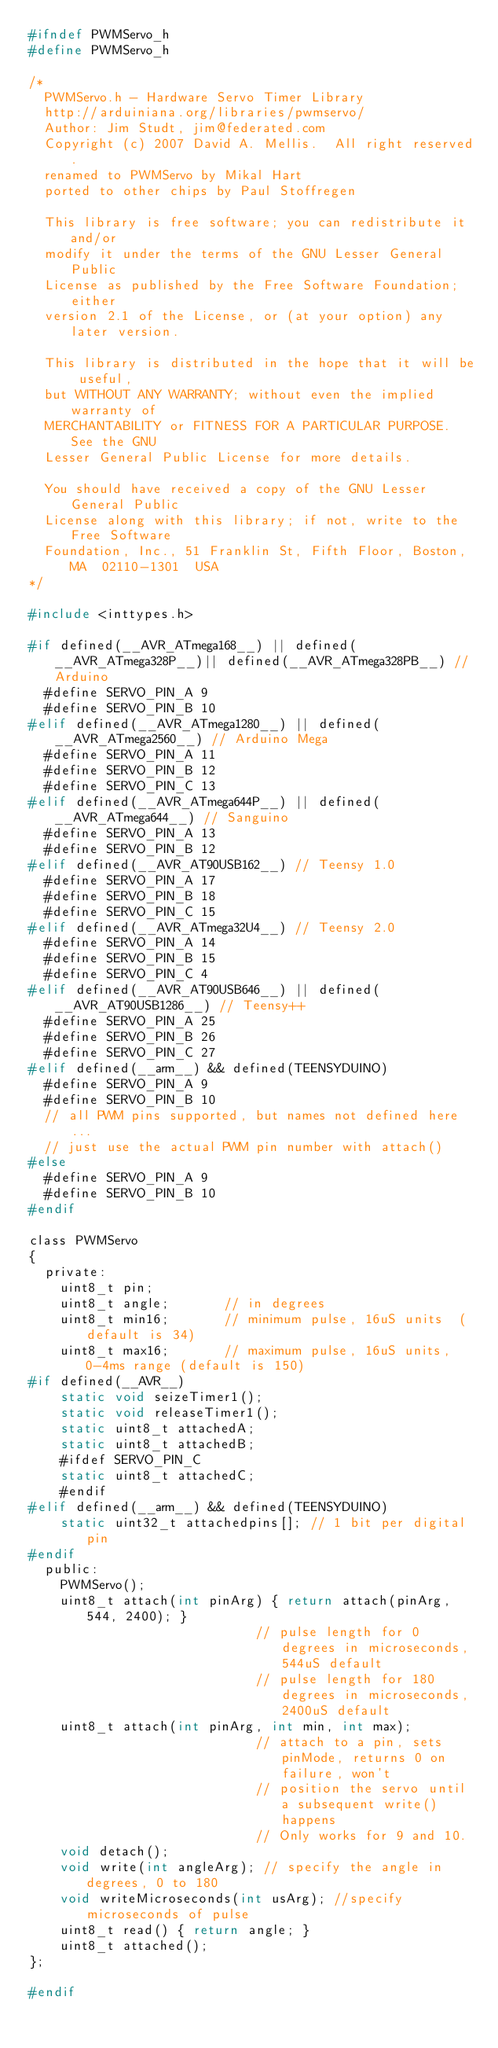Convert code to text. <code><loc_0><loc_0><loc_500><loc_500><_C_>#ifndef PWMServo_h
#define PWMServo_h

/*
  PWMServo.h - Hardware Servo Timer Library
  http://arduiniana.org/libraries/pwmservo/
  Author: Jim Studt, jim@federated.com
  Copyright (c) 2007 David A. Mellis.  All right reserved.
  renamed to PWMServo by Mikal Hart
  ported to other chips by Paul Stoffregen

  This library is free software; you can redistribute it and/or
  modify it under the terms of the GNU Lesser General Public
  License as published by the Free Software Foundation; either
  version 2.1 of the License, or (at your option) any later version.

  This library is distributed in the hope that it will be useful,
  but WITHOUT ANY WARRANTY; without even the implied warranty of
  MERCHANTABILITY or FITNESS FOR A PARTICULAR PURPOSE.  See the GNU
  Lesser General Public License for more details.

  You should have received a copy of the GNU Lesser General Public
  License along with this library; if not, write to the Free Software
  Foundation, Inc., 51 Franklin St, Fifth Floor, Boston, MA  02110-1301  USA
*/

#include <inttypes.h>

#if defined(__AVR_ATmega168__) || defined(__AVR_ATmega328P__)|| defined(__AVR_ATmega328PB__) // Arduino
  #define SERVO_PIN_A 9
  #define SERVO_PIN_B 10
#elif defined(__AVR_ATmega1280__) || defined(__AVR_ATmega2560__) // Arduino Mega
  #define SERVO_PIN_A 11
  #define SERVO_PIN_B 12
  #define SERVO_PIN_C 13
#elif defined(__AVR_ATmega644P__) || defined(__AVR_ATmega644__) // Sanguino
  #define SERVO_PIN_A 13
  #define SERVO_PIN_B 12
#elif defined(__AVR_AT90USB162__) // Teensy 1.0
  #define SERVO_PIN_A 17
  #define SERVO_PIN_B 18
  #define SERVO_PIN_C 15
#elif defined(__AVR_ATmega32U4__) // Teensy 2.0
  #define SERVO_PIN_A 14
  #define SERVO_PIN_B 15
  #define SERVO_PIN_C 4
#elif defined(__AVR_AT90USB646__) || defined(__AVR_AT90USB1286__) // Teensy++
  #define SERVO_PIN_A 25
  #define SERVO_PIN_B 26
  #define SERVO_PIN_C 27
#elif defined(__arm__) && defined(TEENSYDUINO)
  #define SERVO_PIN_A 9
  #define SERVO_PIN_B 10
  // all PWM pins supported, but names not defined here...
  // just use the actual PWM pin number with attach()
#else
  #define SERVO_PIN_A 9
  #define SERVO_PIN_B 10
#endif

class PWMServo
{
  private:
    uint8_t pin;
    uint8_t angle;       // in degrees
    uint8_t min16;       // minimum pulse, 16uS units  (default is 34)
    uint8_t max16;       // maximum pulse, 16uS units, 0-4ms range (default is 150)
#if defined(__AVR__)
    static void seizeTimer1();
    static void releaseTimer1();
    static uint8_t attachedA;
    static uint8_t attachedB;
    #ifdef SERVO_PIN_C
    static uint8_t attachedC;
    #endif
#elif defined(__arm__) && defined(TEENSYDUINO)
    static uint32_t attachedpins[]; // 1 bit per digital pin
#endif
  public:
    PWMServo();
    uint8_t attach(int pinArg) { return attach(pinArg, 544, 2400); }
                             // pulse length for 0 degrees in microseconds, 544uS default
                             // pulse length for 180 degrees in microseconds, 2400uS default
    uint8_t attach(int pinArg, int min, int max);
                             // attach to a pin, sets pinMode, returns 0 on failure, won't
                             // position the servo until a subsequent write() happens
                             // Only works for 9 and 10.
    void detach();
    void write(int angleArg); // specify the angle in degrees, 0 to 180
    void writeMicroseconds(int usArg); //specify microseconds of pulse
    uint8_t read() { return angle; }
    uint8_t attached();
};

#endif
</code> 